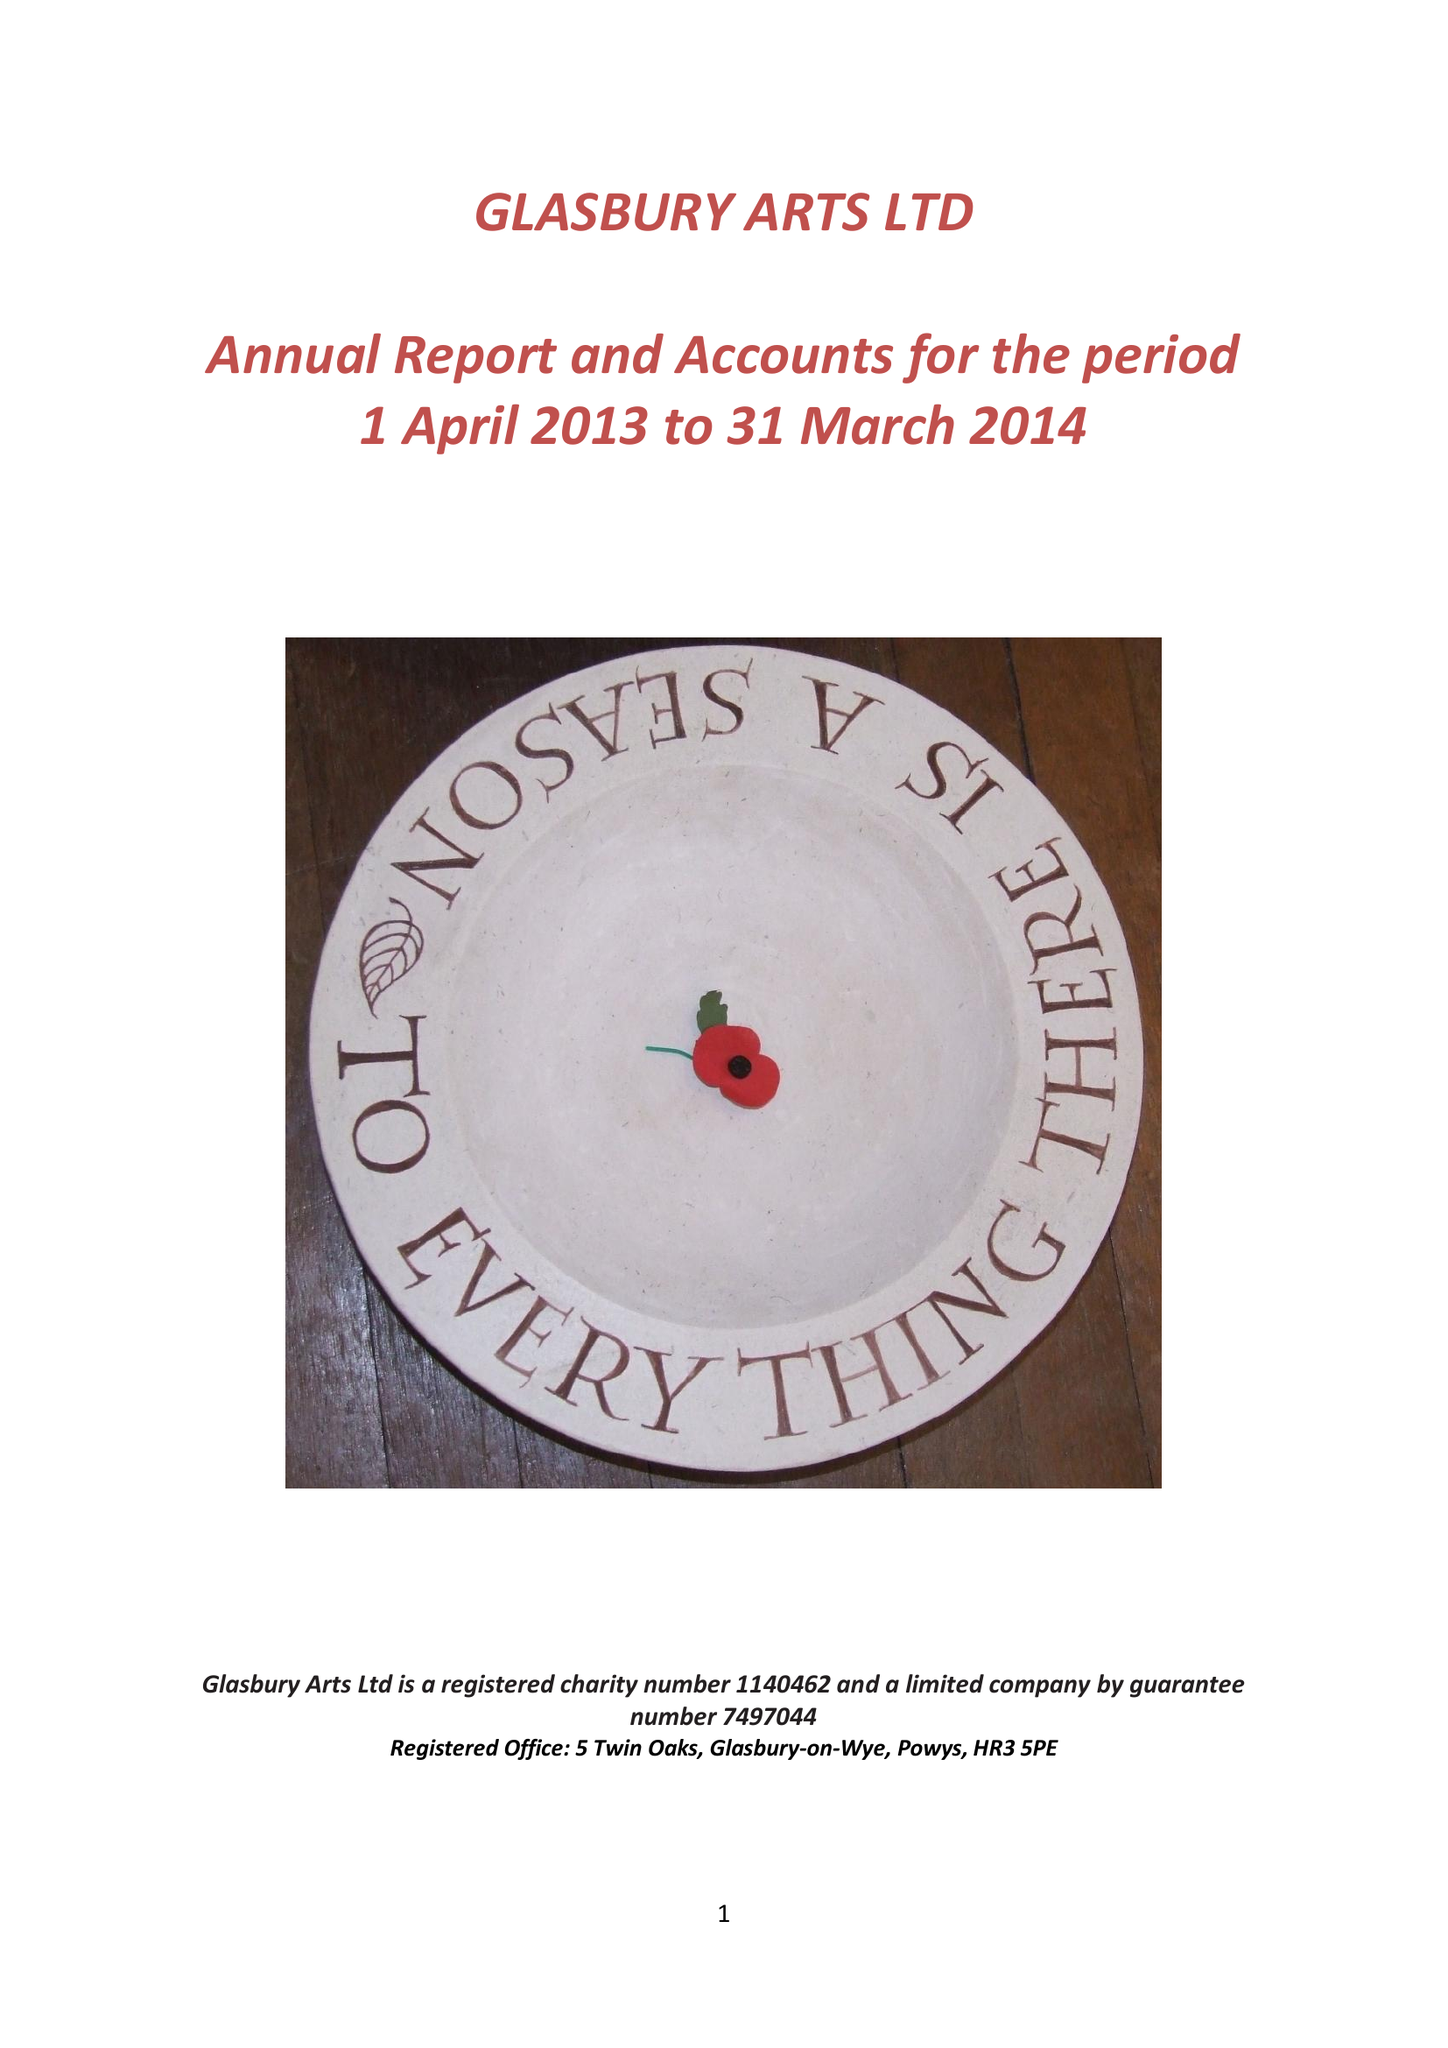What is the value for the spending_annually_in_british_pounds?
Answer the question using a single word or phrase. 33346.00 